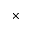<formula> <loc_0><loc_0><loc_500><loc_500>\times</formula> 